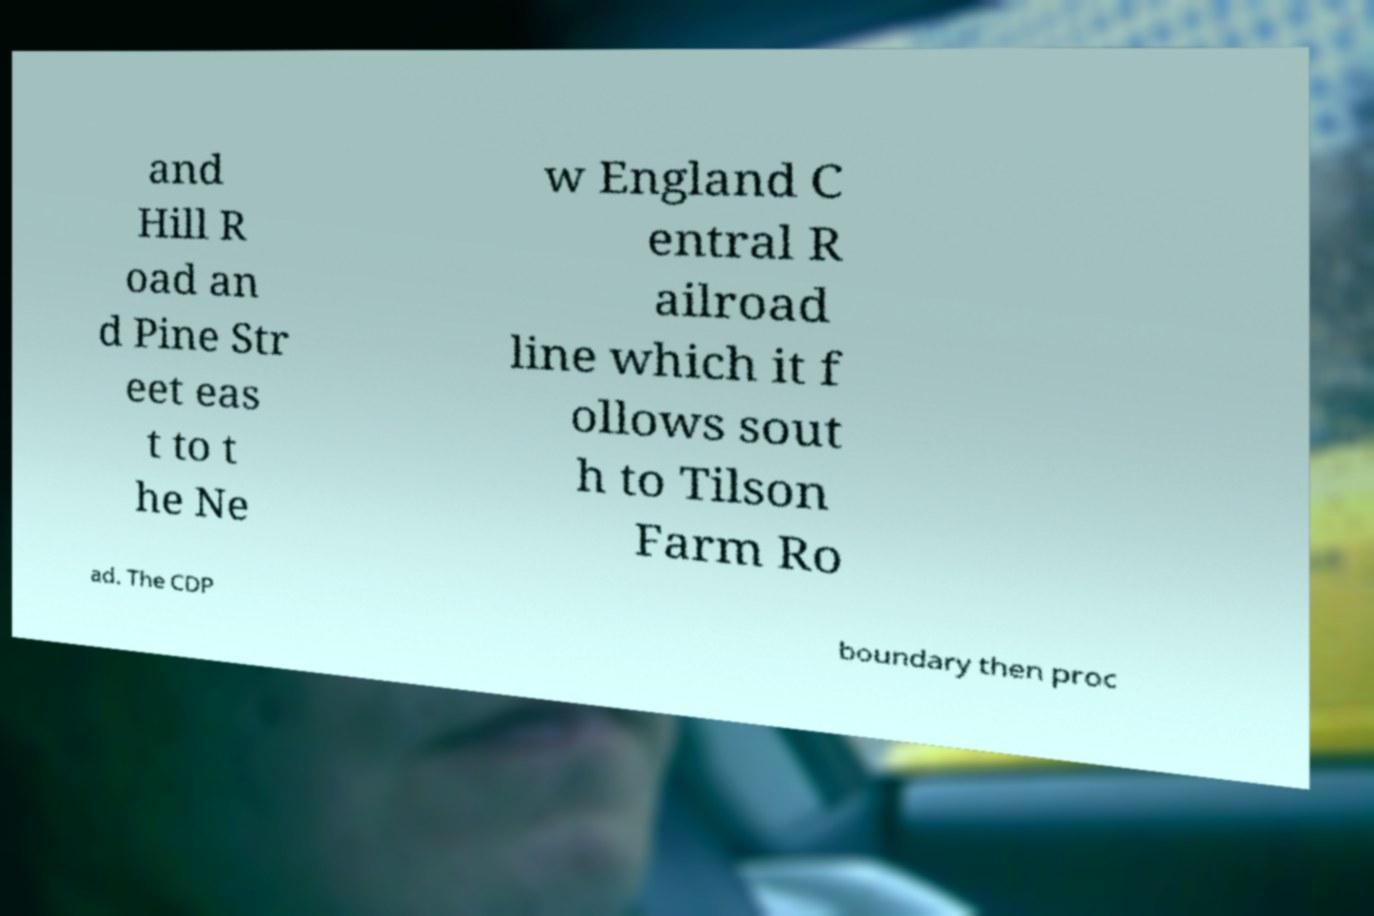Please read and relay the text visible in this image. What does it say? and Hill R oad an d Pine Str eet eas t to t he Ne w England C entral R ailroad line which it f ollows sout h to Tilson Farm Ro ad. The CDP boundary then proc 